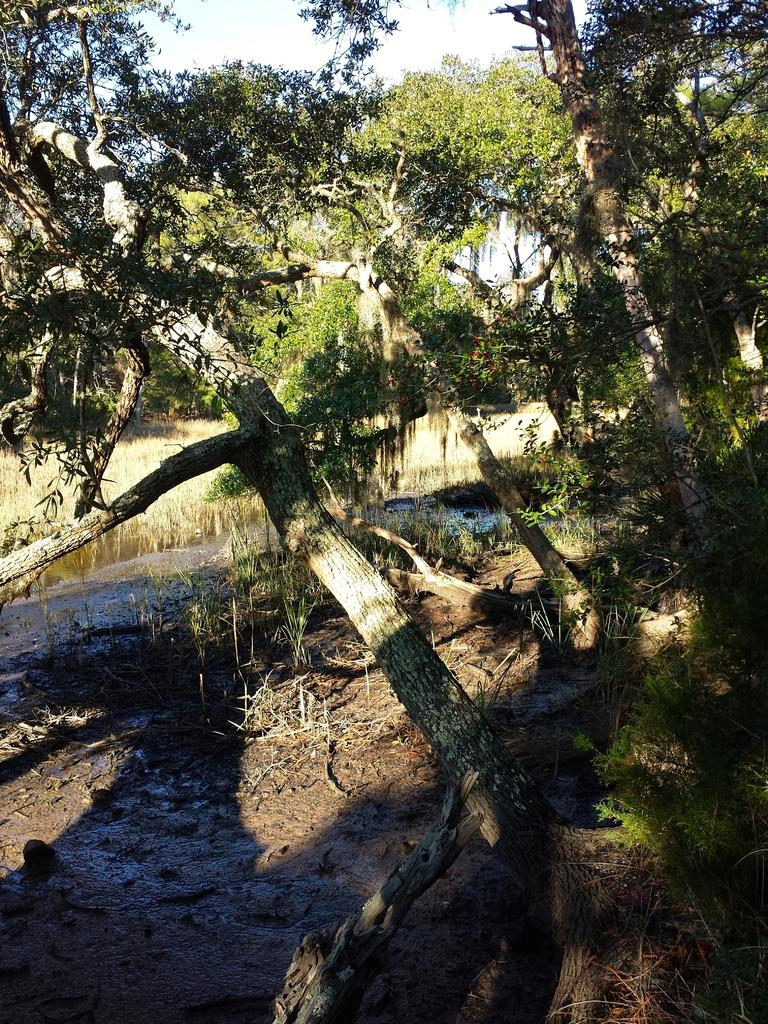What type of surface can be seen in the image? There is ground visible in the image. What type of vegetation is present in the image? There are trees in the image. What colors are the trees in the image? The trees are green and brown in color. What is visible in the background of the image? The sky is visible in the background of the image. Where is the tub located in the image? There is no tub present in the image. What type of fruit is hanging from the trees in the image? The trees in the image are not described as having fruit, so it cannot be determined what type of fruit might be hanging from them. 